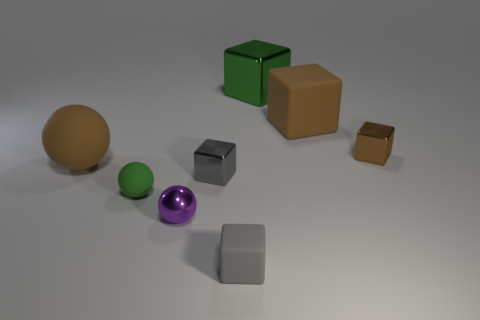Subtract all green cubes. How many cubes are left? 4 Subtract all tiny brown metal blocks. How many blocks are left? 4 Subtract 1 blocks. How many blocks are left? 4 Subtract all purple cubes. Subtract all green cylinders. How many cubes are left? 5 Add 1 green matte balls. How many objects exist? 9 Subtract all spheres. How many objects are left? 5 Subtract all large gray blocks. Subtract all small gray cubes. How many objects are left? 6 Add 5 brown spheres. How many brown spheres are left? 6 Add 2 cyan shiny cylinders. How many cyan shiny cylinders exist? 2 Subtract 0 green cylinders. How many objects are left? 8 